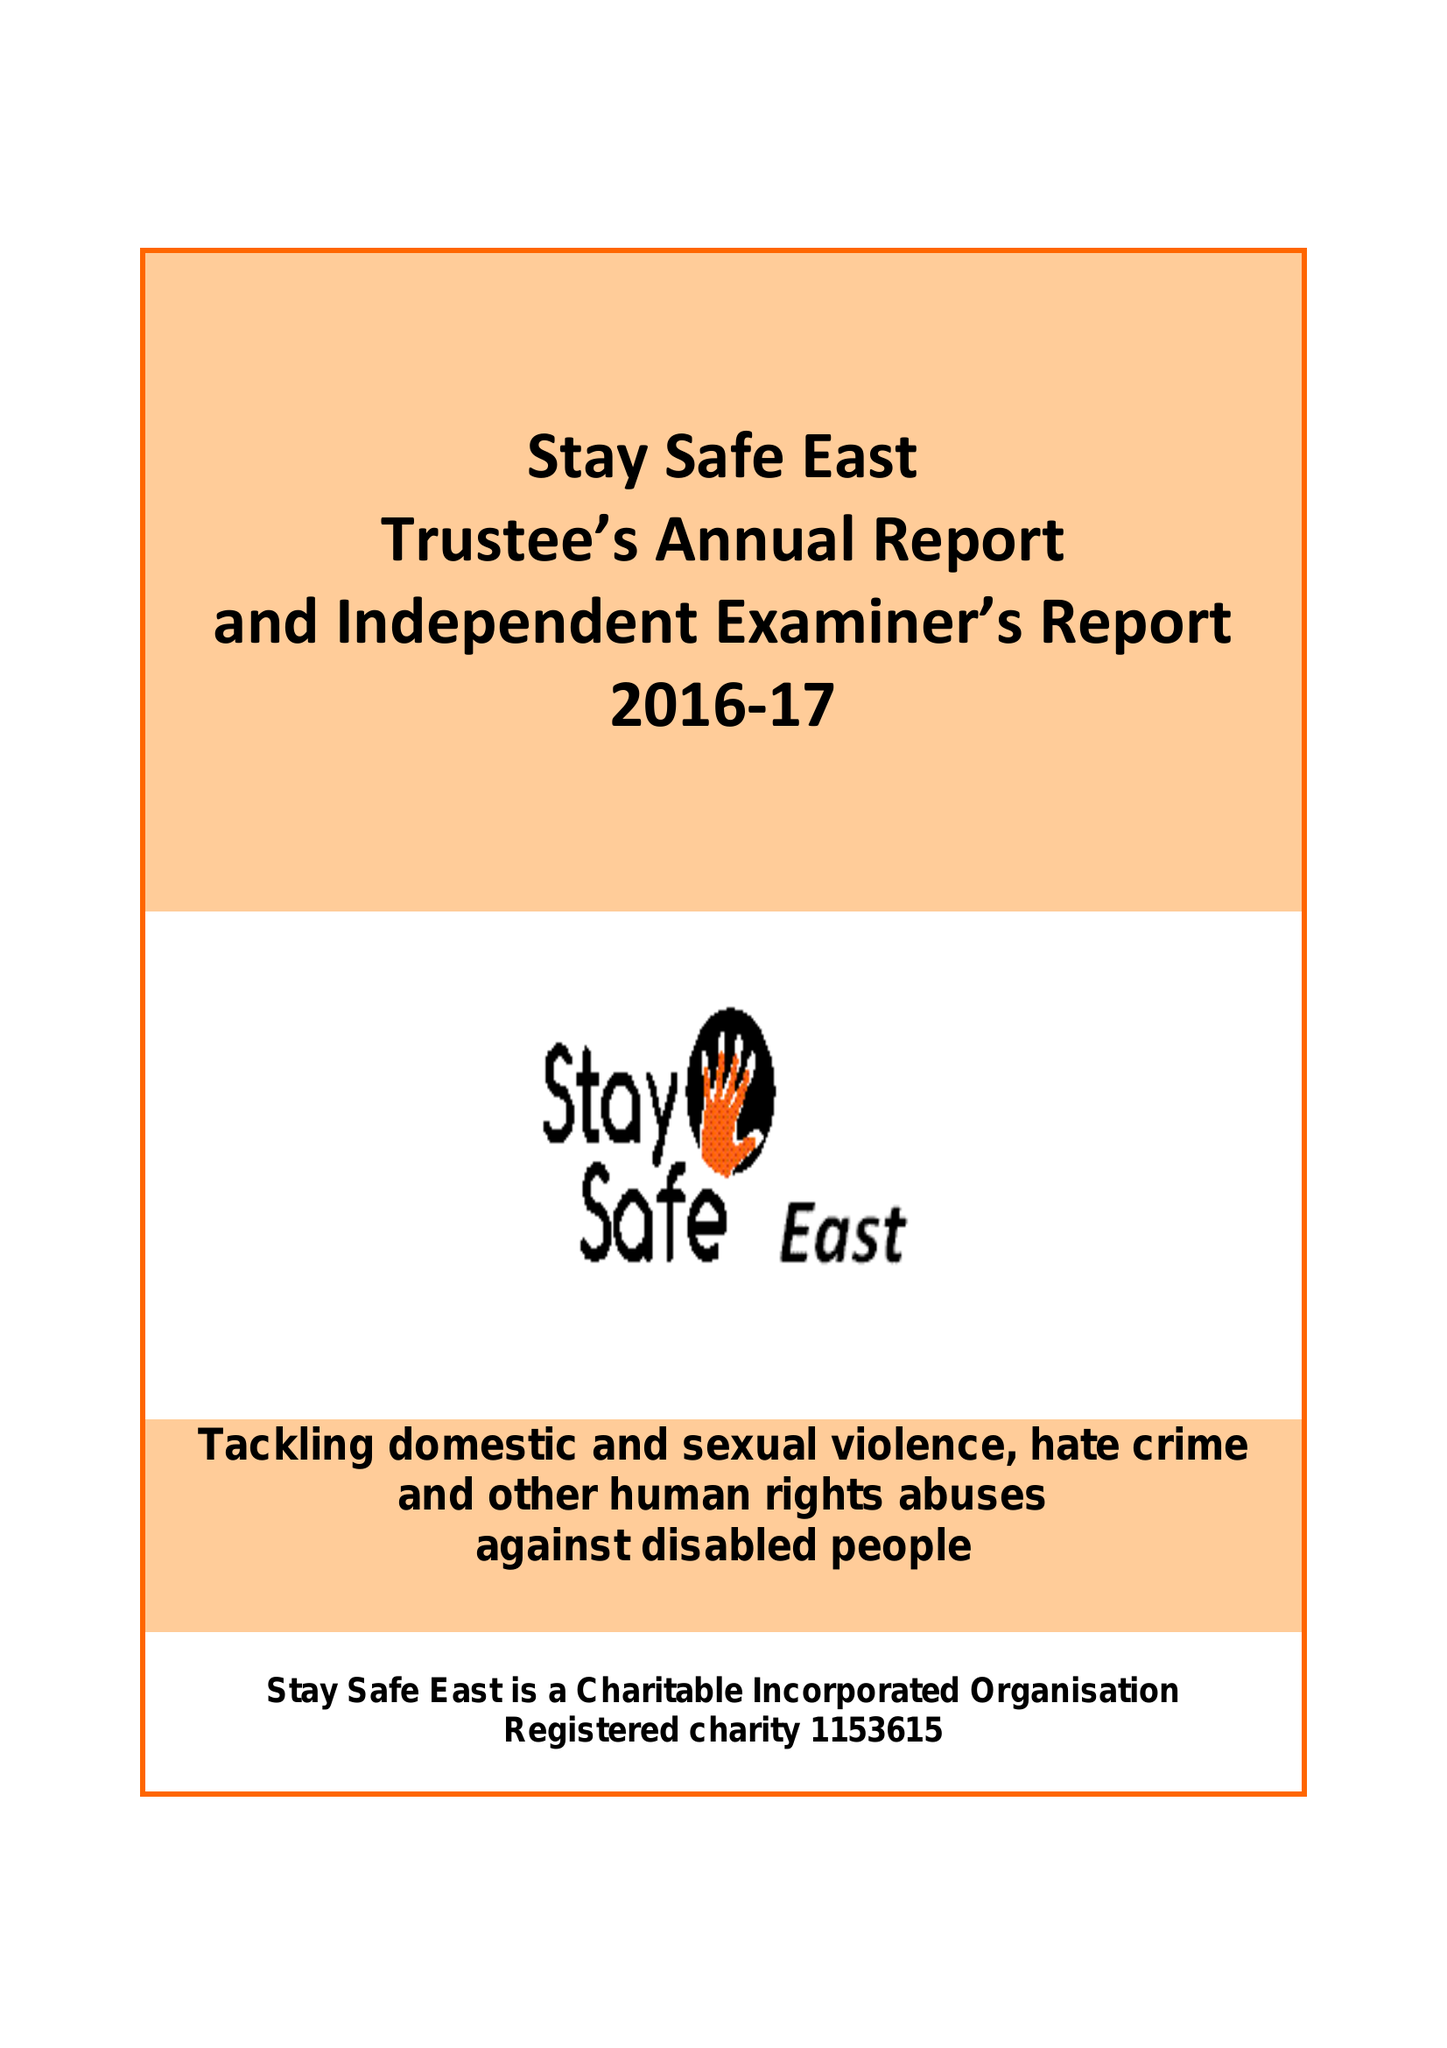What is the value for the report_date?
Answer the question using a single word or phrase. 2017-03-31 